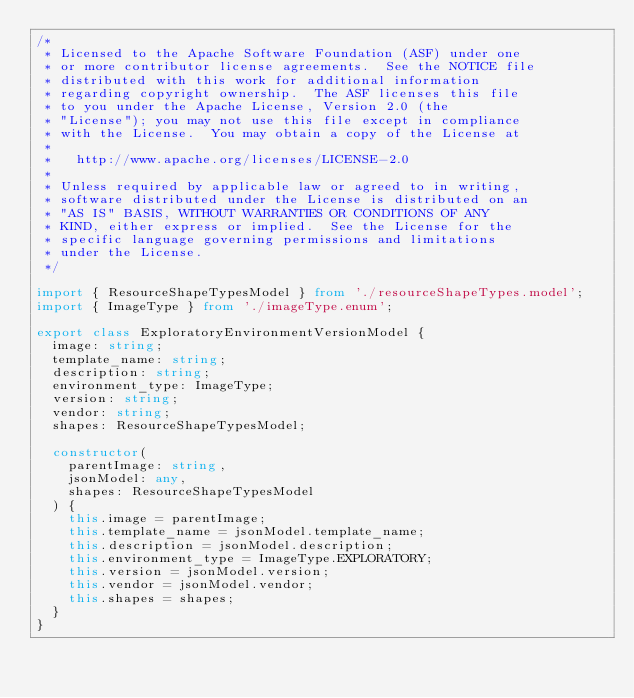Convert code to text. <code><loc_0><loc_0><loc_500><loc_500><_TypeScript_>/*
 * Licensed to the Apache Software Foundation (ASF) under one
 * or more contributor license agreements.  See the NOTICE file
 * distributed with this work for additional information
 * regarding copyright ownership.  The ASF licenses this file
 * to you under the Apache License, Version 2.0 (the
 * "License"); you may not use this file except in compliance
 * with the License.  You may obtain a copy of the License at
 *
 *   http://www.apache.org/licenses/LICENSE-2.0
 *
 * Unless required by applicable law or agreed to in writing,
 * software distributed under the License is distributed on an
 * "AS IS" BASIS, WITHOUT WARRANTIES OR CONDITIONS OF ANY
 * KIND, either express or implied.  See the License for the
 * specific language governing permissions and limitations
 * under the License.
 */

import { ResourceShapeTypesModel } from './resourceShapeTypes.model';
import { ImageType } from './imageType.enum';

export class ExploratoryEnvironmentVersionModel {
  image: string;
  template_name: string;
  description: string;
  environment_type: ImageType;
  version: string;
  vendor: string;
  shapes: ResourceShapeTypesModel;

  constructor(
    parentImage: string,
    jsonModel: any,
    shapes: ResourceShapeTypesModel
  ) {
    this.image = parentImage;
    this.template_name = jsonModel.template_name;
    this.description = jsonModel.description;
    this.environment_type = ImageType.EXPLORATORY;
    this.version = jsonModel.version;
    this.vendor = jsonModel.vendor;
    this.shapes = shapes;
  }
}
</code> 